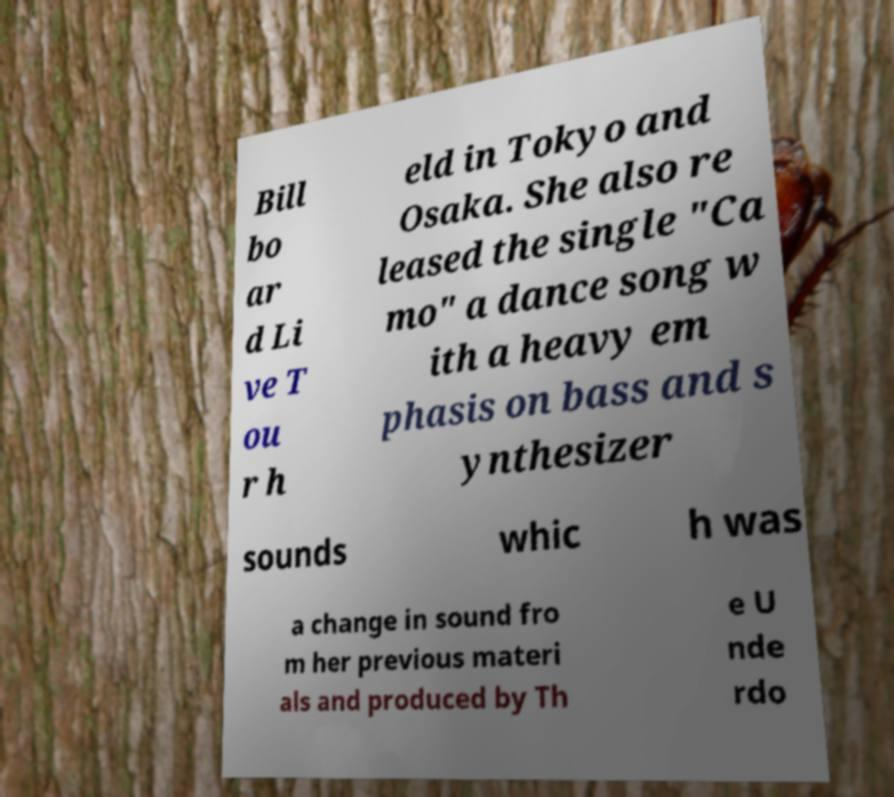Could you assist in decoding the text presented in this image and type it out clearly? Bill bo ar d Li ve T ou r h eld in Tokyo and Osaka. She also re leased the single "Ca mo" a dance song w ith a heavy em phasis on bass and s ynthesizer sounds whic h was a change in sound fro m her previous materi als and produced by Th e U nde rdo 